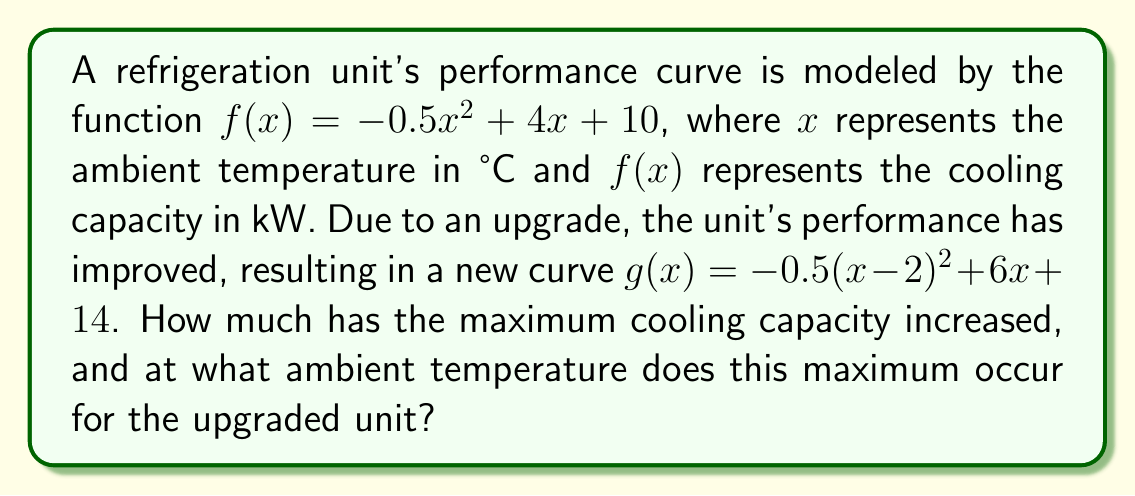What is the answer to this math problem? 1) First, let's analyze the transformation from $f(x)$ to $g(x)$:
   $g(x) = -0.5(x-2)^2 + 6x + 14$
   This represents a horizontal shift of 2 units right and a vertical stretch and shift.

2) To find the maximum cooling capacity, we need to find the vertex of the parabola $g(x)$:
   For a quadratic function in the form $a(x-h)^2 + k$, the vertex is at $(h,k)$.
   Rewriting $g(x)$ in this form:
   $g(x) = -0.5(x-2)^2 + 6x + 14$
         $= -0.5(x^2-4x+4) + 6x + 14$
         $= -0.5x^2 + 2x - 2 + 6x + 14$
         $= -0.5x^2 + 8x + 12$
         $= -0.5(x^2 - 16x) + 12$
         $= -0.5(x^2 - 16x + 64 - 64) + 12$
         $= -0.5((x-8)^2 - 64) + 12$
         $= -0.5(x-8)^2 + 32 + 12$
         $= -0.5(x-8)^2 + 44$

3) From this form, we can see that the vertex of $g(x)$ is at $(8, 44)$.
   This means the maximum cooling capacity is 44 kW at 8°C.

4) For the original function $f(x)$, we can find its vertex similarly:
   $f(x) = -0.5x^2 + 4x + 10$
         $= -0.5(x^2 - 8x) + 10$
         $= -0.5(x^2 - 8x + 16 - 16) + 10$
         $= -0.5((x-4)^2 - 16) + 10$
         $= -0.5(x-4)^2 + 8 + 10$
         $= -0.5(x-4)^2 + 18$

5) The vertex of $f(x)$ is at $(4, 18)$.

6) The increase in maximum cooling capacity is:
   $44 - 18 = 26$ kW
Answer: 26 kW increase; maximum at 8°C 